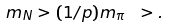Convert formula to latex. <formula><loc_0><loc_0><loc_500><loc_500>m _ { N } > ( 1 / p ) m _ { \pi } \ > .</formula> 